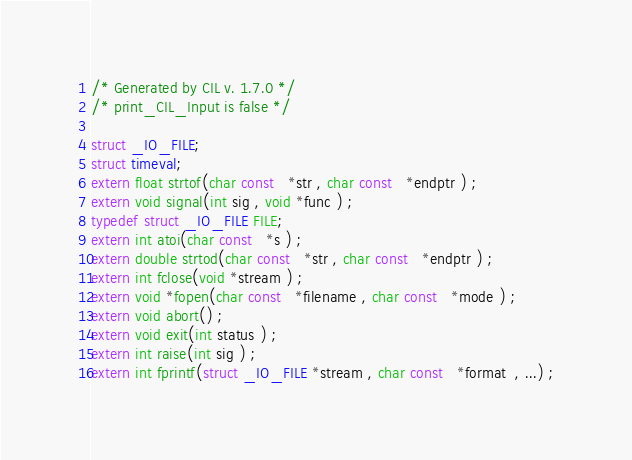Convert code to text. <code><loc_0><loc_0><loc_500><loc_500><_C_>/* Generated by CIL v. 1.7.0 */
/* print_CIL_Input is false */

struct _IO_FILE;
struct timeval;
extern float strtof(char const   *str , char const   *endptr ) ;
extern void signal(int sig , void *func ) ;
typedef struct _IO_FILE FILE;
extern int atoi(char const   *s ) ;
extern double strtod(char const   *str , char const   *endptr ) ;
extern int fclose(void *stream ) ;
extern void *fopen(char const   *filename , char const   *mode ) ;
extern void abort() ;
extern void exit(int status ) ;
extern int raise(int sig ) ;
extern int fprintf(struct _IO_FILE *stream , char const   *format  , ...) ;</code> 